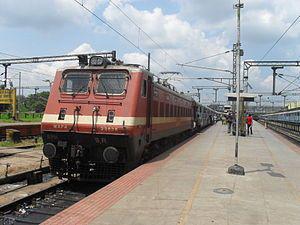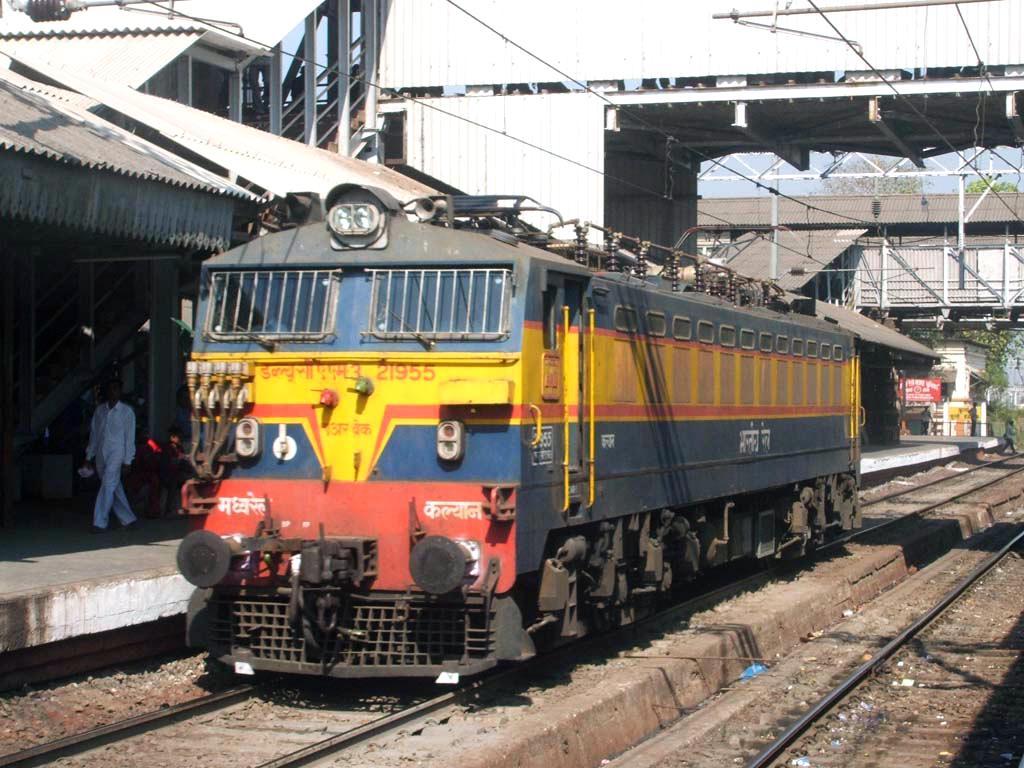The first image is the image on the left, the second image is the image on the right. Analyze the images presented: Is the assertion "None of the trains have their headlights on and none of the them are decorated with balloons." valid? Answer yes or no. Yes. The first image is the image on the left, the second image is the image on the right. Given the left and right images, does the statement "Two trains are angled so as to travel in the same direction when they move." hold true? Answer yes or no. Yes. 